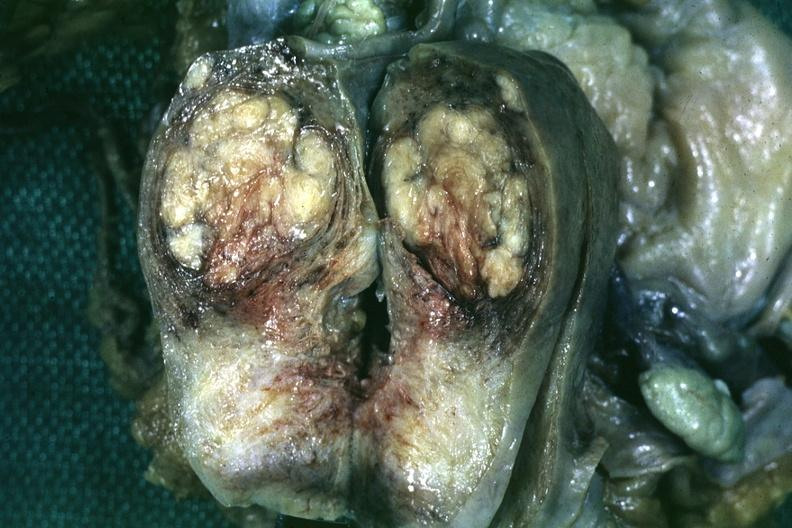what is present?
Answer the question using a single word or phrase. Female reproductive 